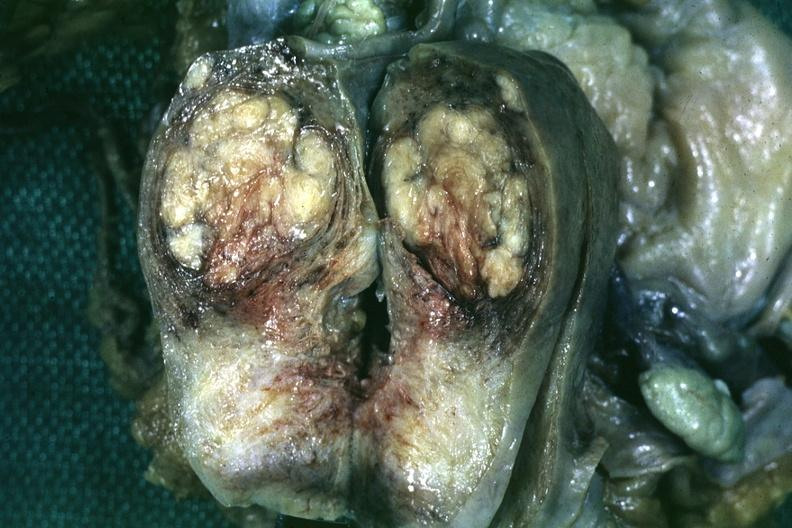what is present?
Answer the question using a single word or phrase. Female reproductive 